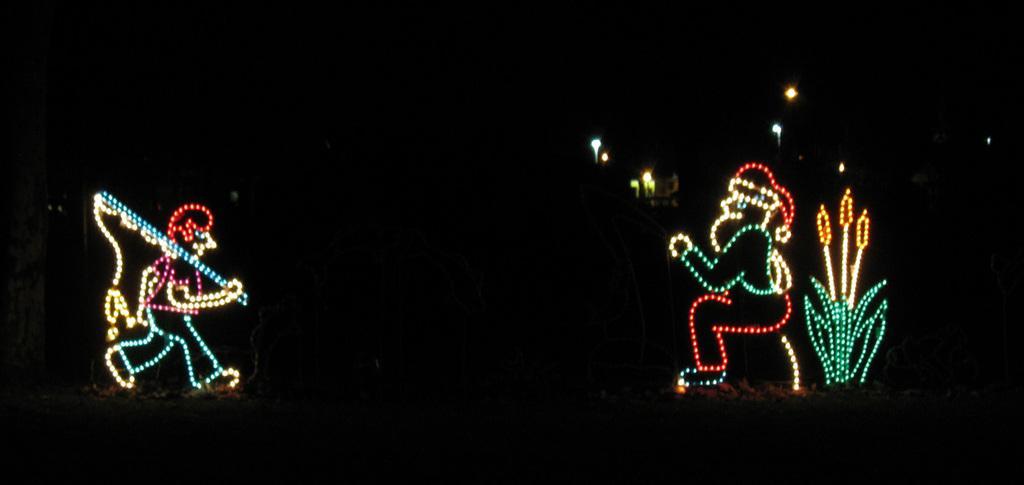Can you describe this image briefly? In this image I can see two people made with lights and the lights are in multicolor and I can see dark background. 